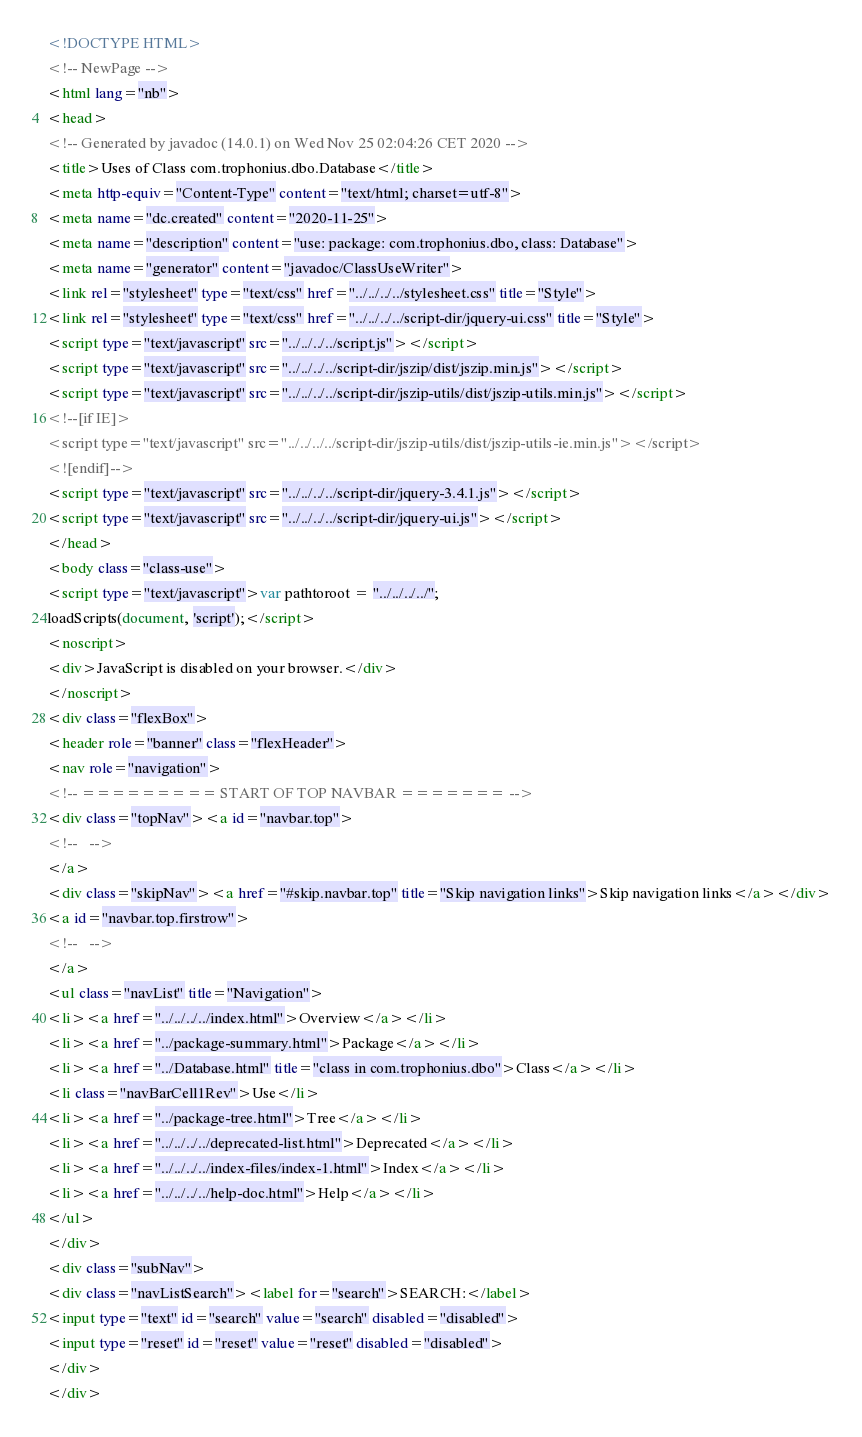<code> <loc_0><loc_0><loc_500><loc_500><_HTML_><!DOCTYPE HTML>
<!-- NewPage -->
<html lang="nb">
<head>
<!-- Generated by javadoc (14.0.1) on Wed Nov 25 02:04:26 CET 2020 -->
<title>Uses of Class com.trophonius.dbo.Database</title>
<meta http-equiv="Content-Type" content="text/html; charset=utf-8">
<meta name="dc.created" content="2020-11-25">
<meta name="description" content="use: package: com.trophonius.dbo, class: Database">
<meta name="generator" content="javadoc/ClassUseWriter">
<link rel="stylesheet" type="text/css" href="../../../../stylesheet.css" title="Style">
<link rel="stylesheet" type="text/css" href="../../../../script-dir/jquery-ui.css" title="Style">
<script type="text/javascript" src="../../../../script.js"></script>
<script type="text/javascript" src="../../../../script-dir/jszip/dist/jszip.min.js"></script>
<script type="text/javascript" src="../../../../script-dir/jszip-utils/dist/jszip-utils.min.js"></script>
<!--[if IE]>
<script type="text/javascript" src="../../../../script-dir/jszip-utils/dist/jszip-utils-ie.min.js"></script>
<![endif]-->
<script type="text/javascript" src="../../../../script-dir/jquery-3.4.1.js"></script>
<script type="text/javascript" src="../../../../script-dir/jquery-ui.js"></script>
</head>
<body class="class-use">
<script type="text/javascript">var pathtoroot = "../../../../";
loadScripts(document, 'script');</script>
<noscript>
<div>JavaScript is disabled on your browser.</div>
</noscript>
<div class="flexBox">
<header role="banner" class="flexHeader">
<nav role="navigation">
<!-- ========= START OF TOP NAVBAR ======= -->
<div class="topNav"><a id="navbar.top">
<!--   -->
</a>
<div class="skipNav"><a href="#skip.navbar.top" title="Skip navigation links">Skip navigation links</a></div>
<a id="navbar.top.firstrow">
<!--   -->
</a>
<ul class="navList" title="Navigation">
<li><a href="../../../../index.html">Overview</a></li>
<li><a href="../package-summary.html">Package</a></li>
<li><a href="../Database.html" title="class in com.trophonius.dbo">Class</a></li>
<li class="navBarCell1Rev">Use</li>
<li><a href="../package-tree.html">Tree</a></li>
<li><a href="../../../../deprecated-list.html">Deprecated</a></li>
<li><a href="../../../../index-files/index-1.html">Index</a></li>
<li><a href="../../../../help-doc.html">Help</a></li>
</ul>
</div>
<div class="subNav">
<div class="navListSearch"><label for="search">SEARCH:</label>
<input type="text" id="search" value="search" disabled="disabled">
<input type="reset" id="reset" value="reset" disabled="disabled">
</div>
</div></code> 